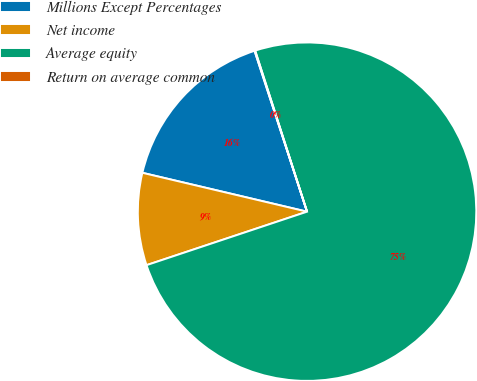Convert chart. <chart><loc_0><loc_0><loc_500><loc_500><pie_chart><fcel>Millions Except Percentages<fcel>Net income<fcel>Average equity<fcel>Return on average common<nl><fcel>16.29%<fcel>8.81%<fcel>74.85%<fcel>0.06%<nl></chart> 